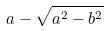<formula> <loc_0><loc_0><loc_500><loc_500>a - \sqrt { a ^ { 2 } - b ^ { 2 } }</formula> 